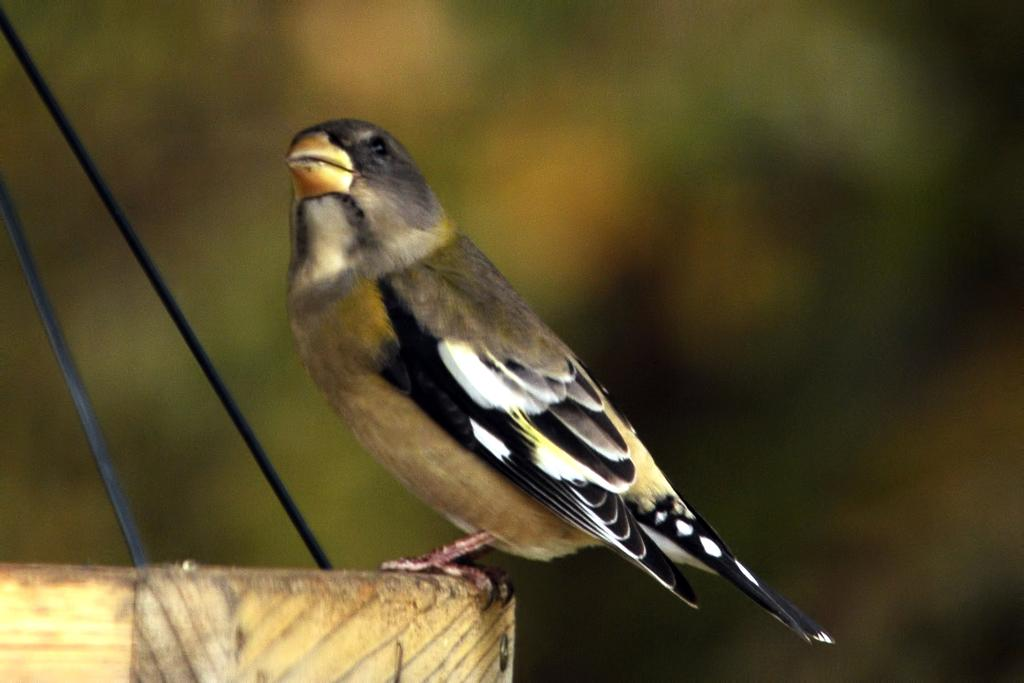What type of animal can be seen in the image? There is a bird present in the image. What type of smile can be seen on the bird's face in the image? Birds do not have facial expressions like humans, so there is no smile visible on the bird's face in the image. What rhythm is the bird dancing to in the image? The image does not depict the bird dancing, so there is no rhythm present. 